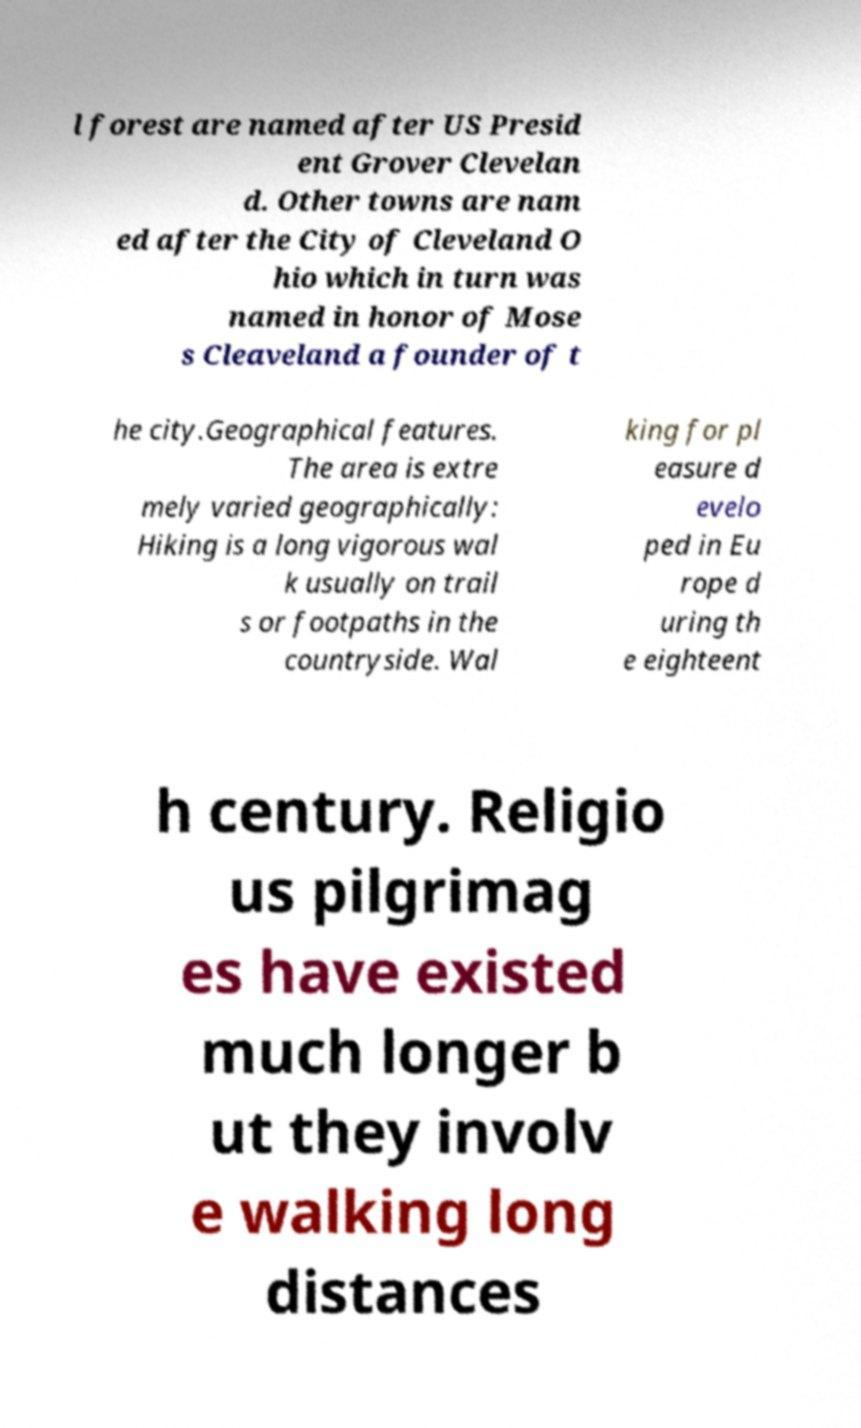There's text embedded in this image that I need extracted. Can you transcribe it verbatim? l forest are named after US Presid ent Grover Clevelan d. Other towns are nam ed after the City of Cleveland O hio which in turn was named in honor of Mose s Cleaveland a founder of t he city.Geographical features. The area is extre mely varied geographically: Hiking is a long vigorous wal k usually on trail s or footpaths in the countryside. Wal king for pl easure d evelo ped in Eu rope d uring th e eighteent h century. Religio us pilgrimag es have existed much longer b ut they involv e walking long distances 